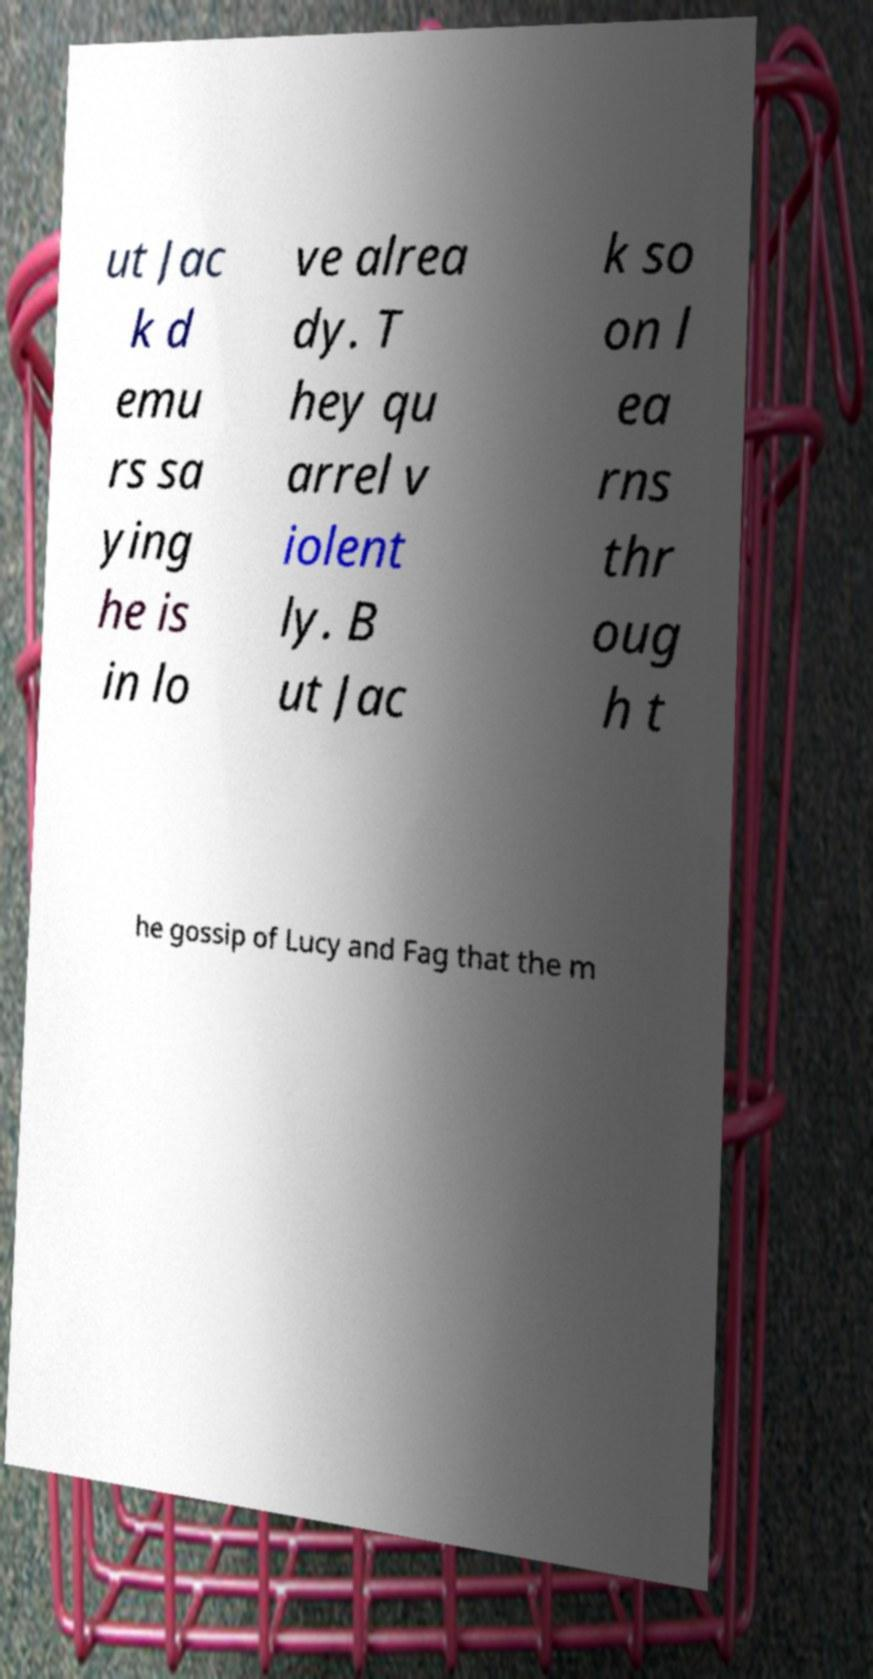Could you extract and type out the text from this image? ut Jac k d emu rs sa ying he is in lo ve alrea dy. T hey qu arrel v iolent ly. B ut Jac k so on l ea rns thr oug h t he gossip of Lucy and Fag that the m 